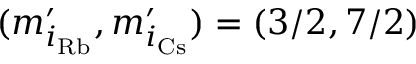Convert formula to latex. <formula><loc_0><loc_0><loc_500><loc_500>( m _ { i _ { R b } } ^ { \prime } , m _ { i _ { C s } } ^ { \prime } ) = ( 3 / 2 , 7 / 2 )</formula> 